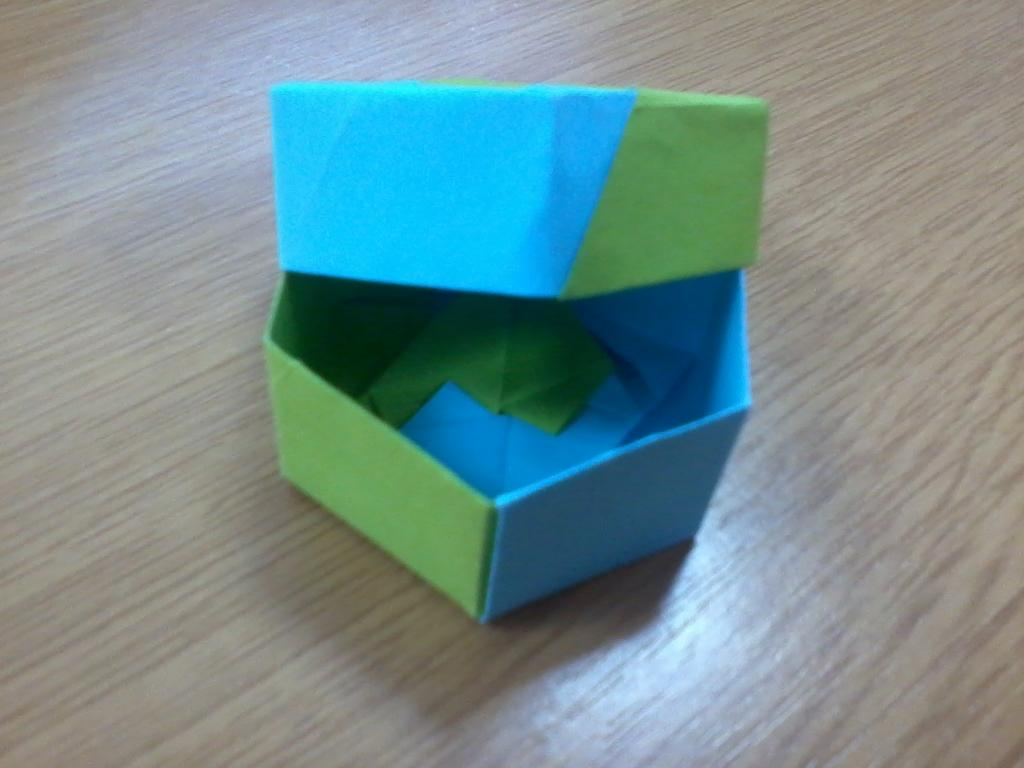What is the main object in the image? There is a box in the image. Where is the box located? The box is placed on a wooden floor. What is the box made of? The box is made of craft papers. What colors are the craft papers? The craft papers are blue and green in color. What type of cheese is being used to create a reaction with the box in the image? There is no cheese present in the image, and therefore no reaction involving cheese can be observed. 